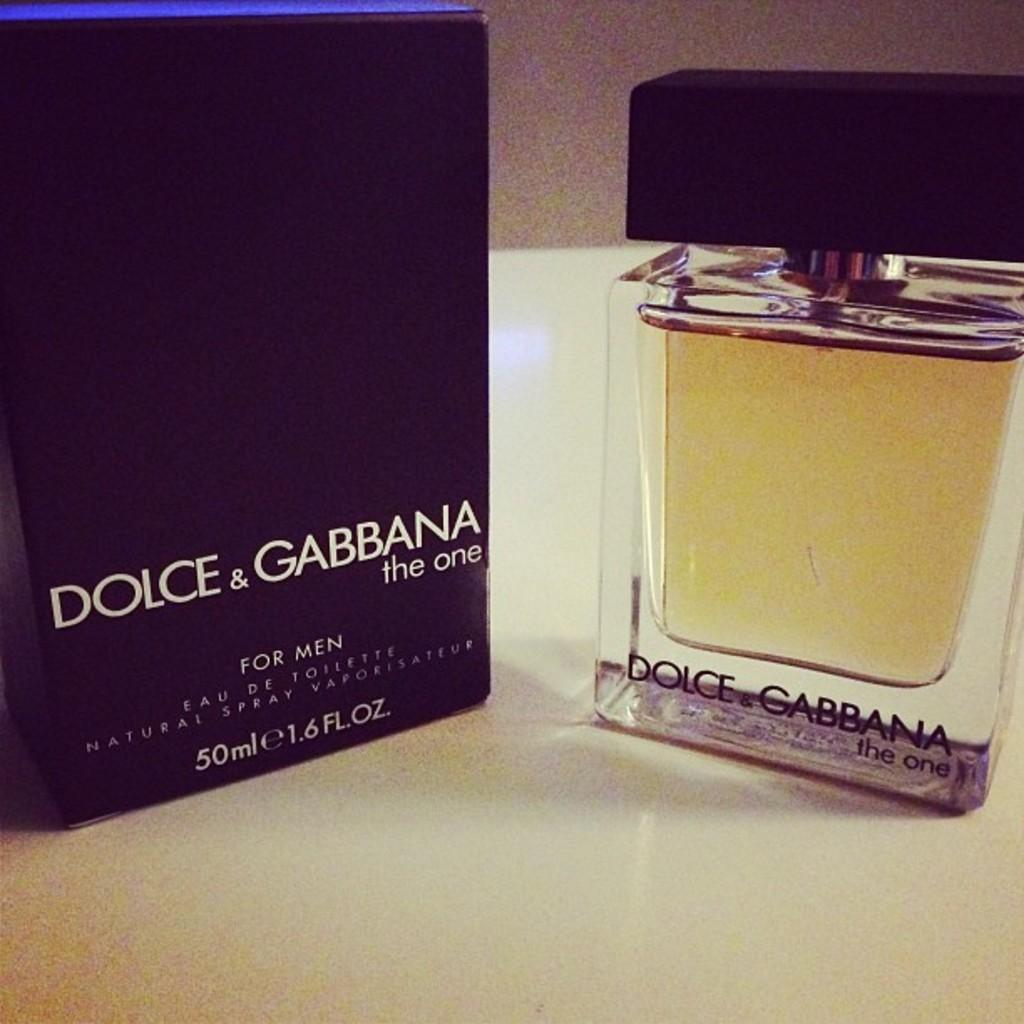Provide a one-sentence caption for the provided image. A black Dolce & Gabbana box next to a clear bottle of cologne. 